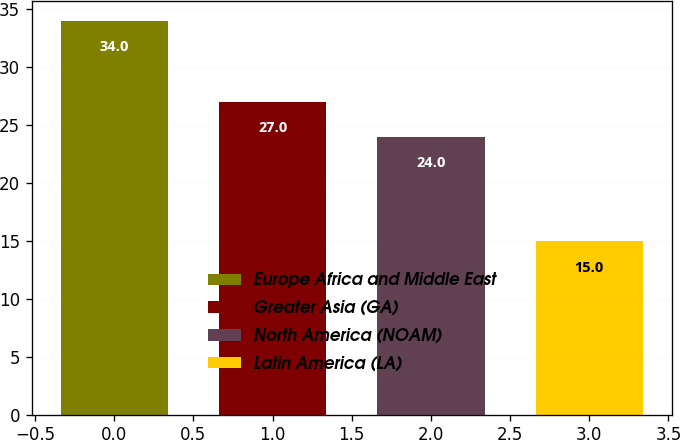Convert chart to OTSL. <chart><loc_0><loc_0><loc_500><loc_500><bar_chart><fcel>Europe Africa and Middle East<fcel>Greater Asia (GA)<fcel>North America (NOAM)<fcel>Latin America (LA)<nl><fcel>34<fcel>27<fcel>24<fcel>15<nl></chart> 